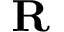Convert formula to latex. <formula><loc_0><loc_0><loc_500><loc_500>R</formula> 